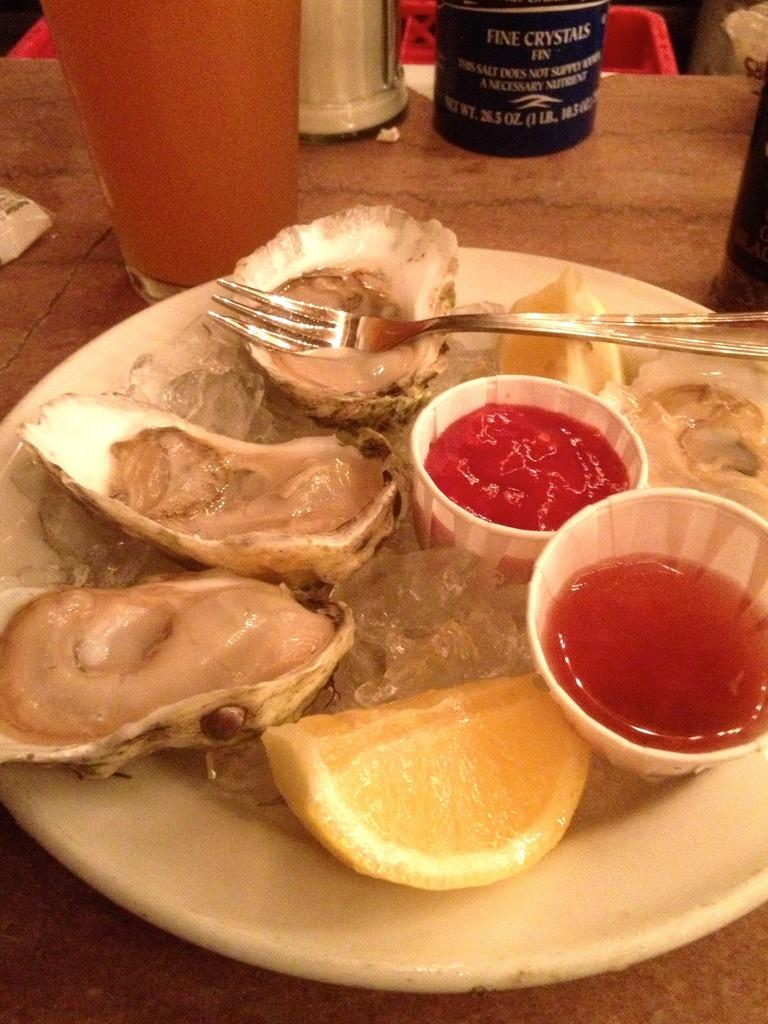What type of food can be seen in the image? There is food in the image, but the specific type cannot be determined from the facts provided. What are the sauce bowls used for in the image? The sauce bowls are likely used for holding sauces or condiments to accompany the food. What is the lemon piece used for in the image? The lemon piece may be used as a garnish or to add flavor to the food. What utensil is present in the plate in the image? There is a fork in the plate in the image. What is the glass of drink on the table in the image? There is a glass of drink on the table in the image, but the type of drink cannot be determined from the facts provided. What are the bottles on the side in the image? The bottles on the side in the image may contain additional sauces, condiments, or drinks. How does the friction between the fork and the plate affect the taste of the food in the image? There is no mention of friction between the fork and the plate in the image, and therefore its effect on the taste of the food cannot be determined. How many kittens are playing with the lemon piece in the image? There are no kittens present in the image; it features food, sauce bowls, a lemon piece, a fork, a glass of drink, and bottles. 